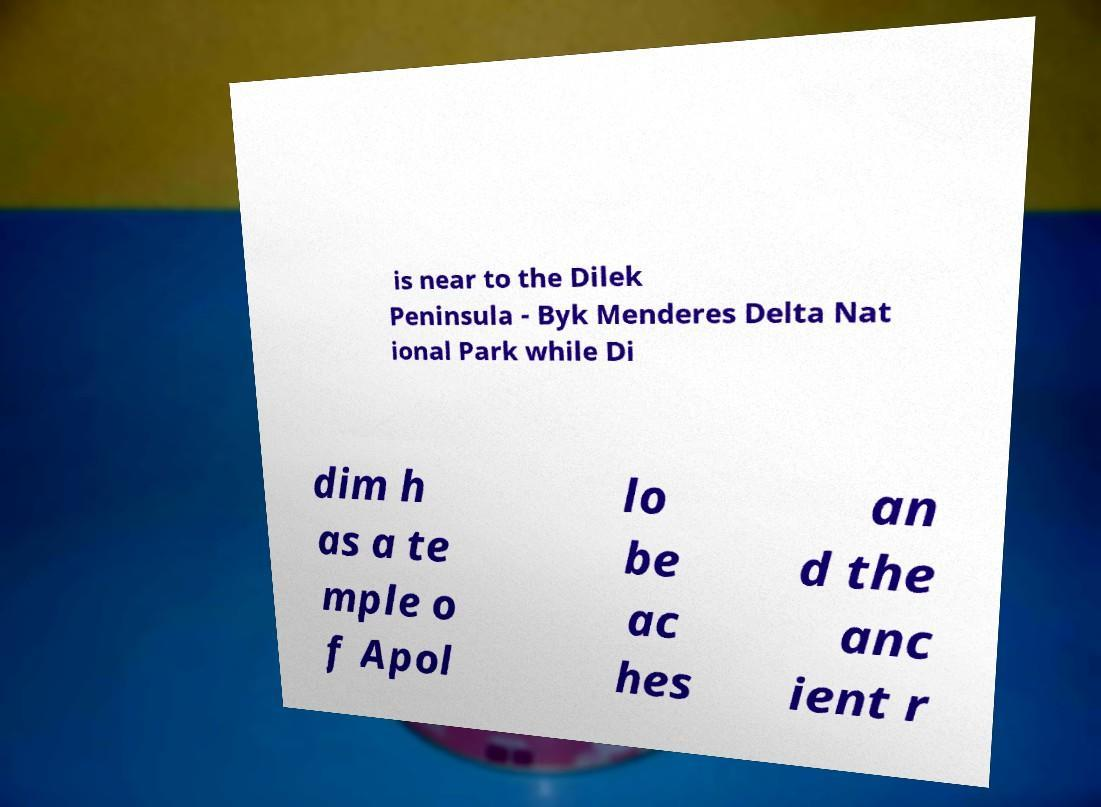Could you assist in decoding the text presented in this image and type it out clearly? is near to the Dilek Peninsula - Byk Menderes Delta Nat ional Park while Di dim h as a te mple o f Apol lo be ac hes an d the anc ient r 